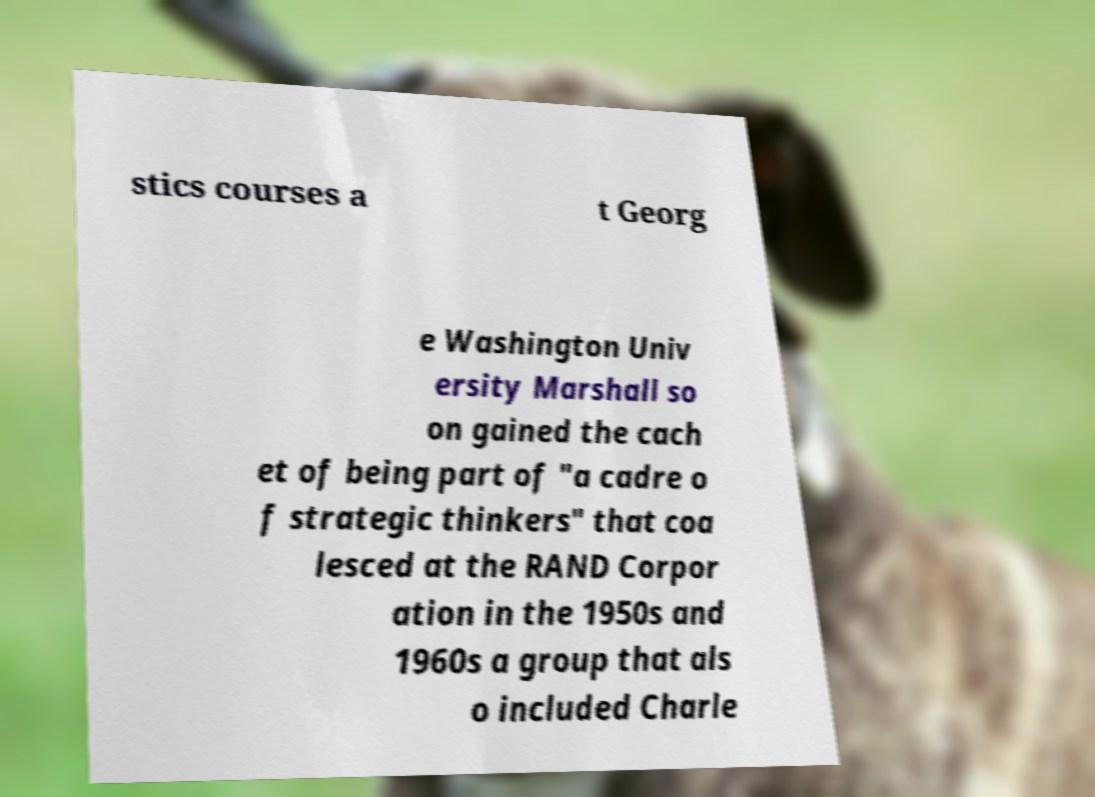Could you assist in decoding the text presented in this image and type it out clearly? stics courses a t Georg e Washington Univ ersity Marshall so on gained the cach et of being part of "a cadre o f strategic thinkers" that coa lesced at the RAND Corpor ation in the 1950s and 1960s a group that als o included Charle 